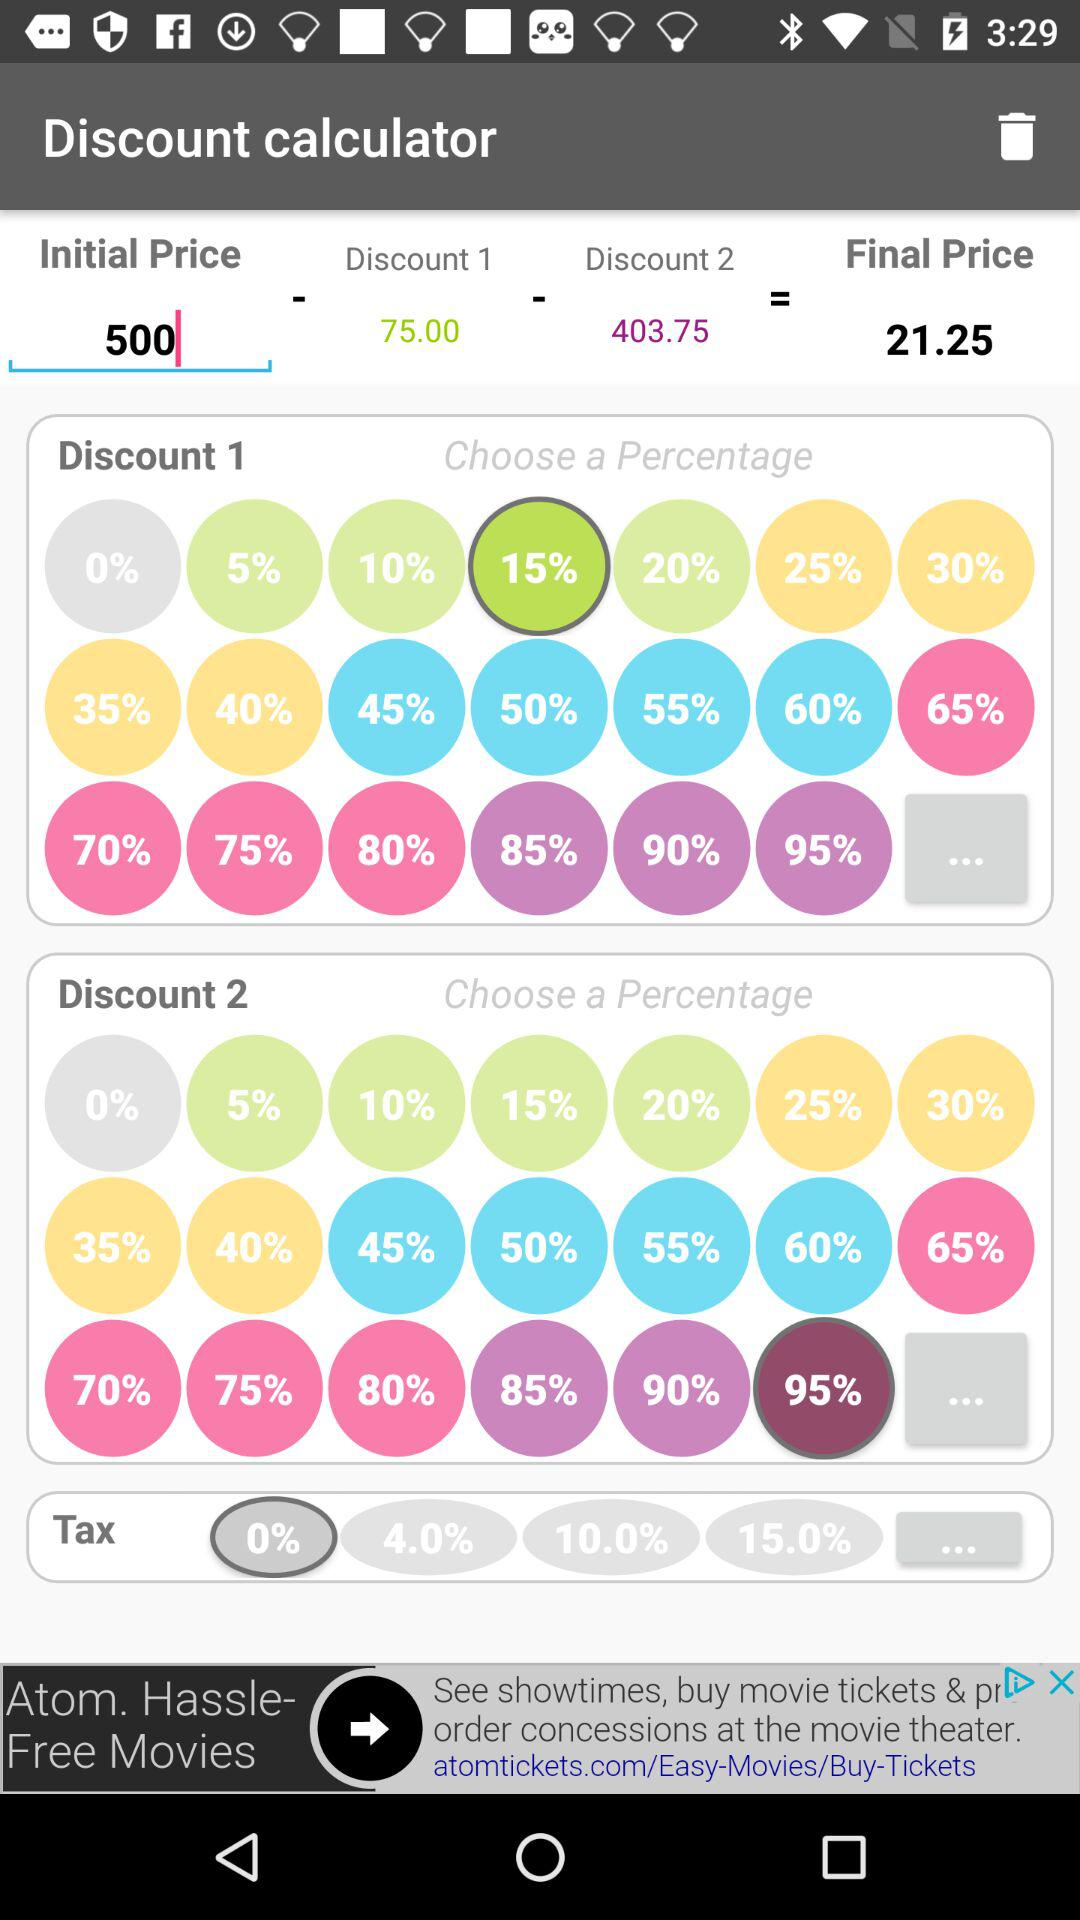What is the final price after tax?
Answer the question using a single word or phrase. 21.25 